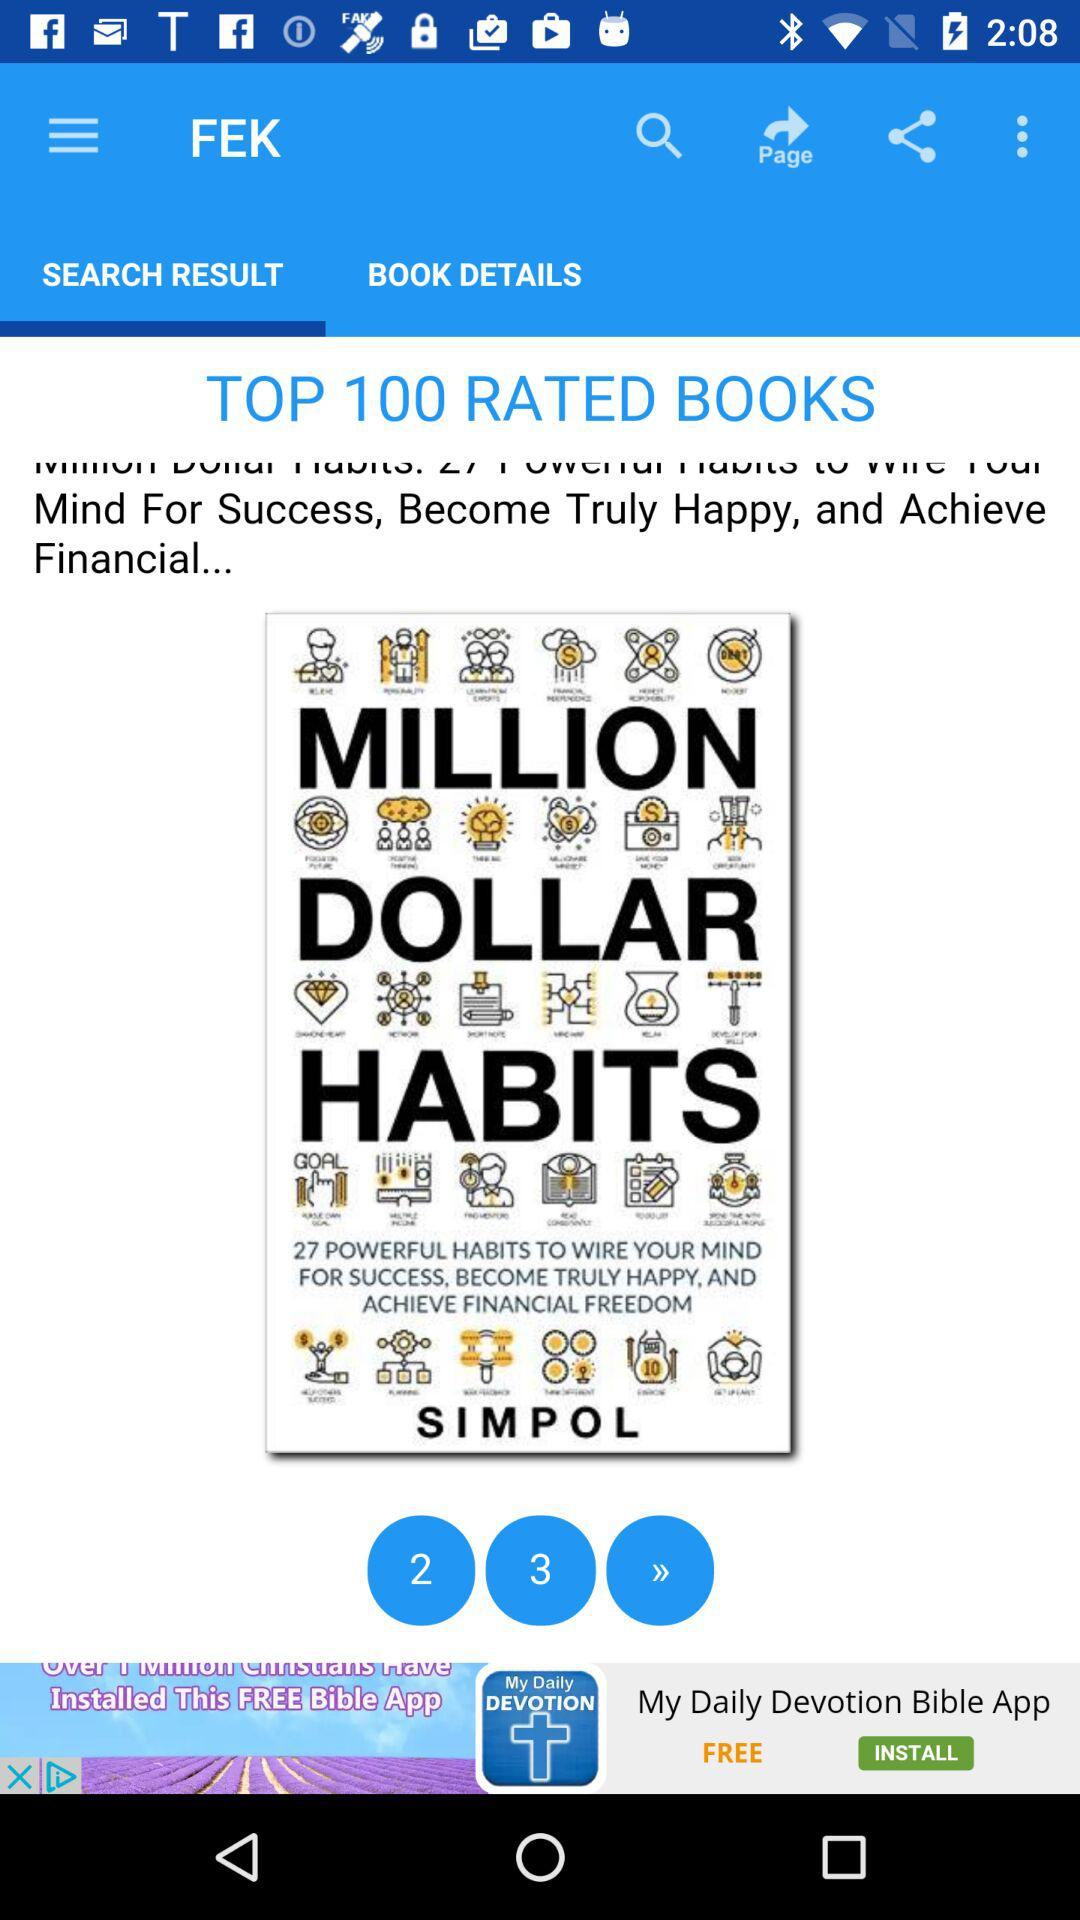Which tab is selected? The selected tab is "SEARCH RESULT". 